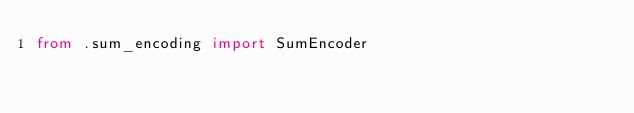Convert code to text. <code><loc_0><loc_0><loc_500><loc_500><_Python_>from .sum_encoding import SumEncoder
</code> 